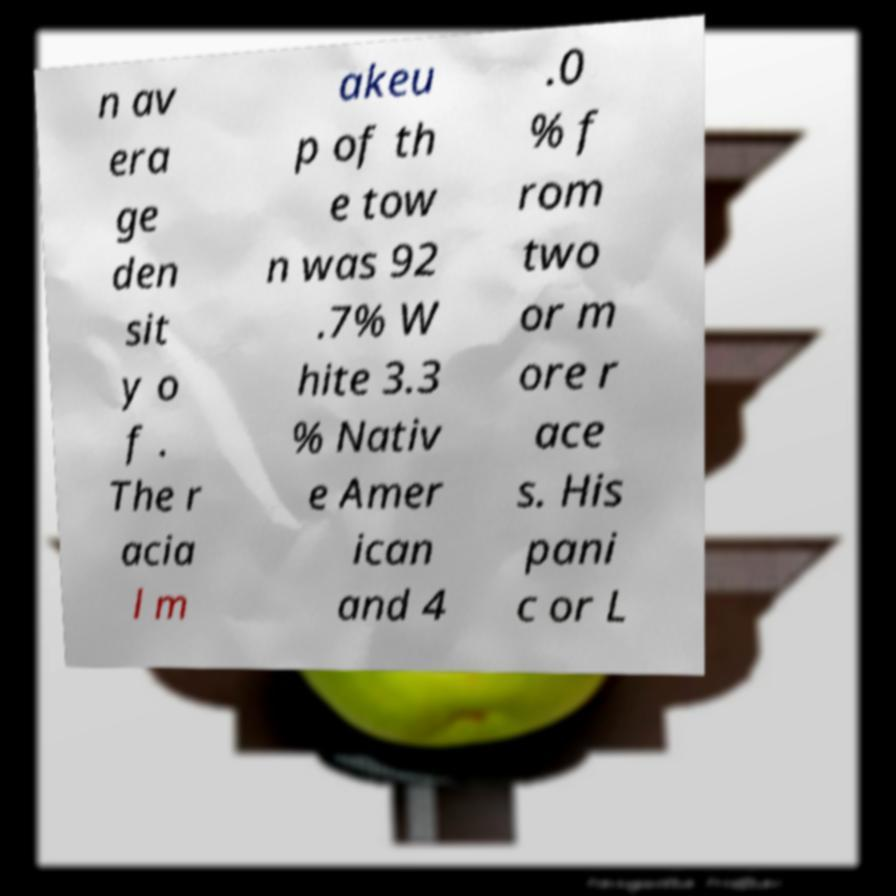There's text embedded in this image that I need extracted. Can you transcribe it verbatim? n av era ge den sit y o f . The r acia l m akeu p of th e tow n was 92 .7% W hite 3.3 % Nativ e Amer ican and 4 .0 % f rom two or m ore r ace s. His pani c or L 